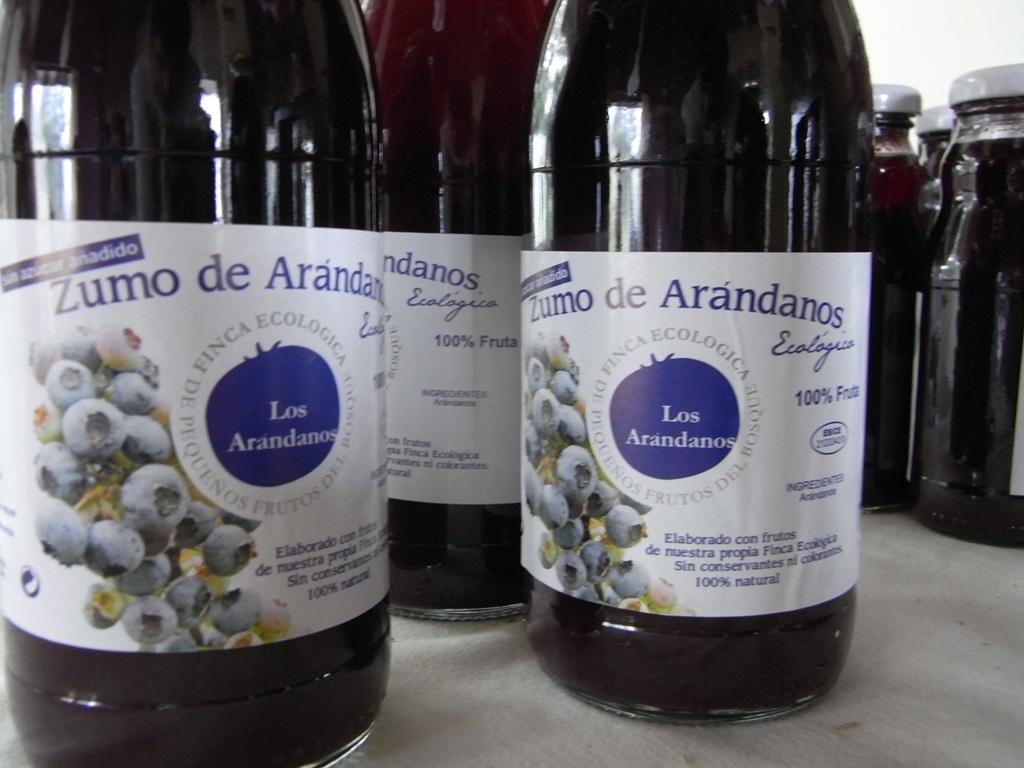How natural is the beverage?
Your response must be concise. 100%. What brand is the beverage?
Your answer should be compact. Zumo de arandanos. 